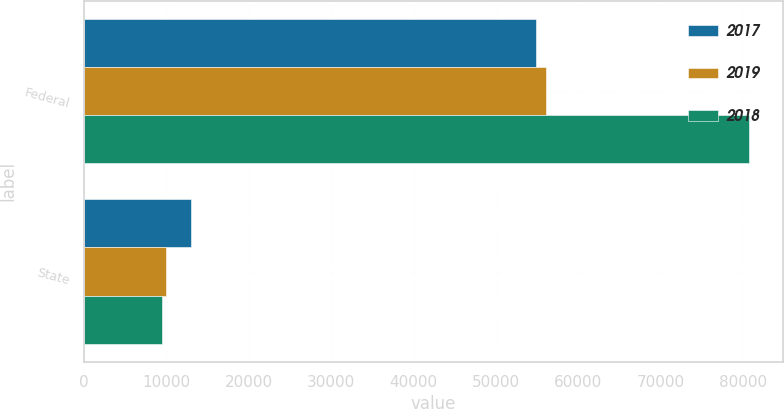Convert chart. <chart><loc_0><loc_0><loc_500><loc_500><stacked_bar_chart><ecel><fcel>Federal<fcel>State<nl><fcel>2017<fcel>54800<fcel>12946<nl><fcel>2019<fcel>56060<fcel>9948<nl><fcel>2018<fcel>80752<fcel>9469<nl></chart> 